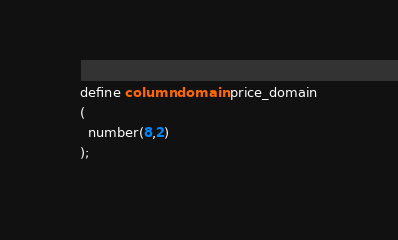<code> <loc_0><loc_0><loc_500><loc_500><_SQL_>define column domain price_domain
(
  number(8,2)
);

</code> 